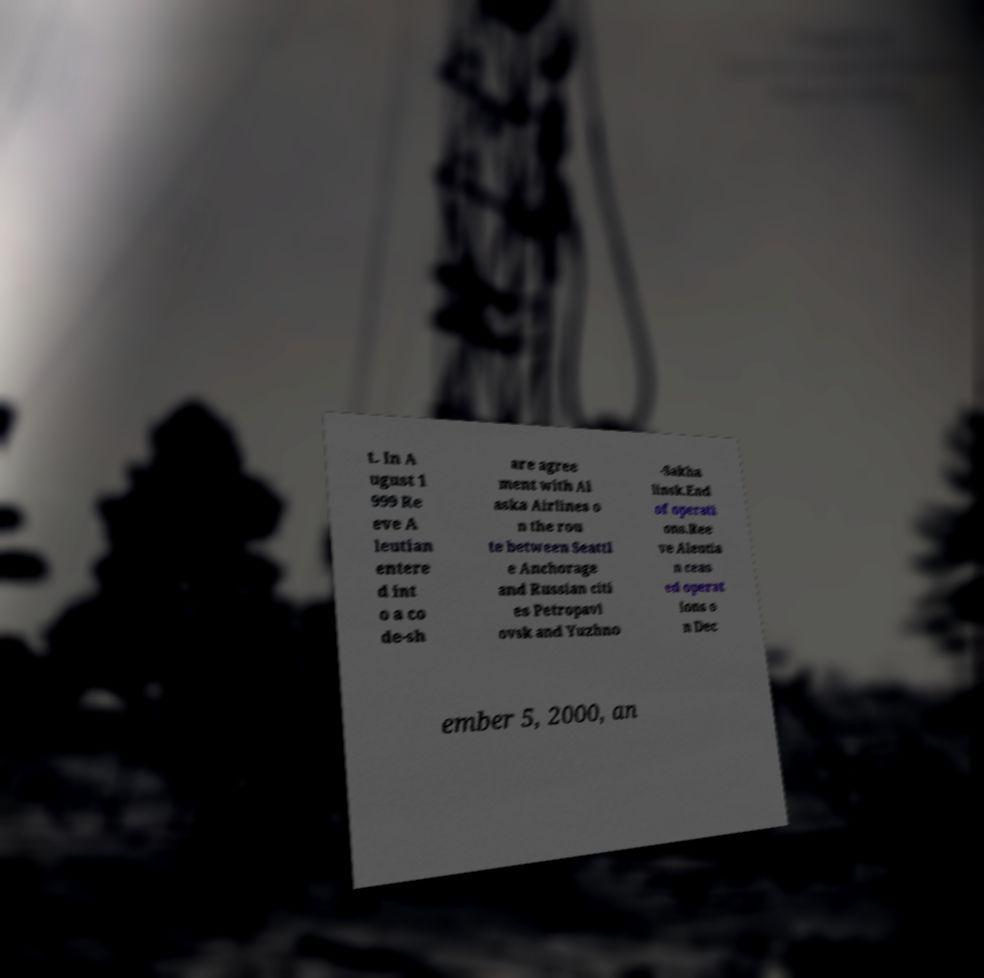Could you extract and type out the text from this image? t. In A ugust 1 999 Re eve A leutian entere d int o a co de-sh are agree ment with Al aska Airlines o n the rou te between Seattl e Anchorage and Russian citi es Petropavl ovsk and Yuzhno -Sakha linsk.End of operati ons.Ree ve Aleutia n ceas ed operat ions o n Dec ember 5, 2000, an 